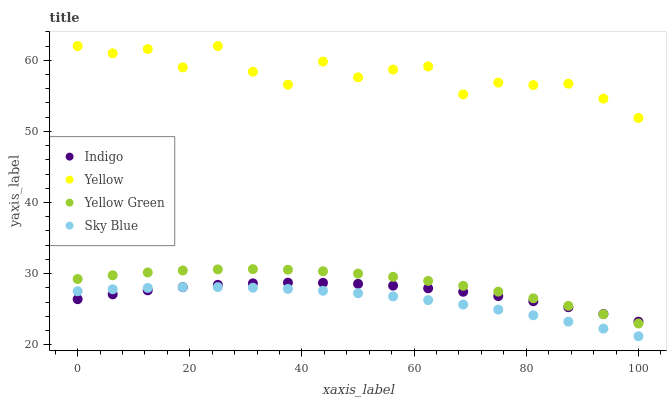Does Sky Blue have the minimum area under the curve?
Answer yes or no. Yes. Does Yellow have the maximum area under the curve?
Answer yes or no. Yes. Does Indigo have the minimum area under the curve?
Answer yes or no. No. Does Indigo have the maximum area under the curve?
Answer yes or no. No. Is Sky Blue the smoothest?
Answer yes or no. Yes. Is Yellow the roughest?
Answer yes or no. Yes. Is Indigo the smoothest?
Answer yes or no. No. Is Indigo the roughest?
Answer yes or no. No. Does Sky Blue have the lowest value?
Answer yes or no. Yes. Does Indigo have the lowest value?
Answer yes or no. No. Does Yellow have the highest value?
Answer yes or no. Yes. Does Indigo have the highest value?
Answer yes or no. No. Is Sky Blue less than Yellow?
Answer yes or no. Yes. Is Yellow greater than Yellow Green?
Answer yes or no. Yes. Does Indigo intersect Yellow Green?
Answer yes or no. Yes. Is Indigo less than Yellow Green?
Answer yes or no. No. Is Indigo greater than Yellow Green?
Answer yes or no. No. Does Sky Blue intersect Yellow?
Answer yes or no. No. 